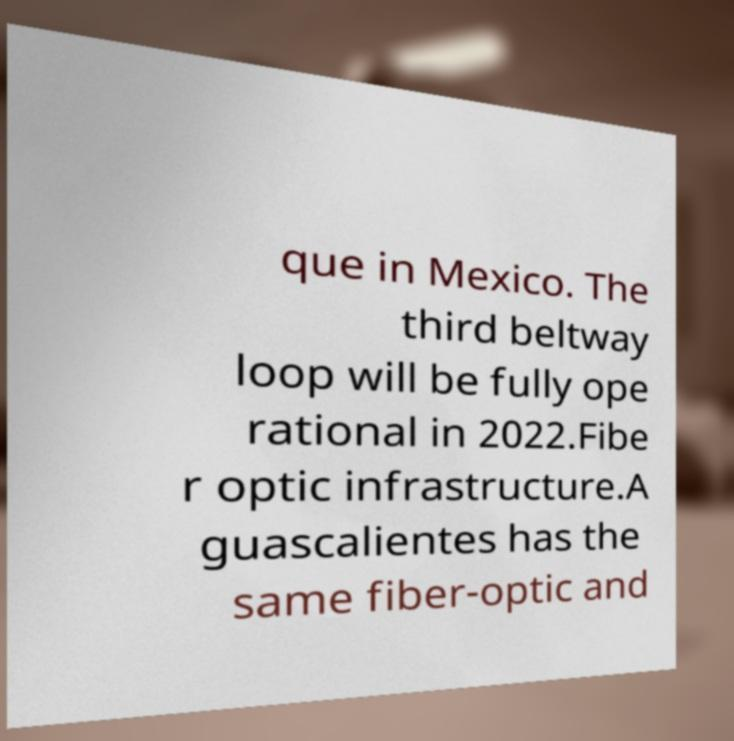For documentation purposes, I need the text within this image transcribed. Could you provide that? que in Mexico. The third beltway loop will be fully ope rational in 2022.Fibe r optic infrastructure.A guascalientes has the same fiber-optic and 